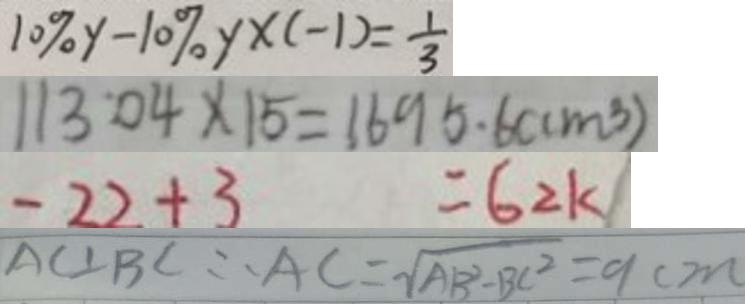Convert formula to latex. <formula><loc_0><loc_0><loc_500><loc_500>1 0 \% y - 1 0 \% y \times ( - 1 ) = \frac { 1 } { 3 } 
 1 1 3 . 0 4 \times 1 5 = 1 6 9 5 . 6 ( c m ^ { 3 } ) 
 - 2 2 + 3 = 6 2 k 
 A C \bot B C \therefore A C = \sqrt { A B ^ { 2 } - B C ^ { 2 } } = 9 c m</formula> 